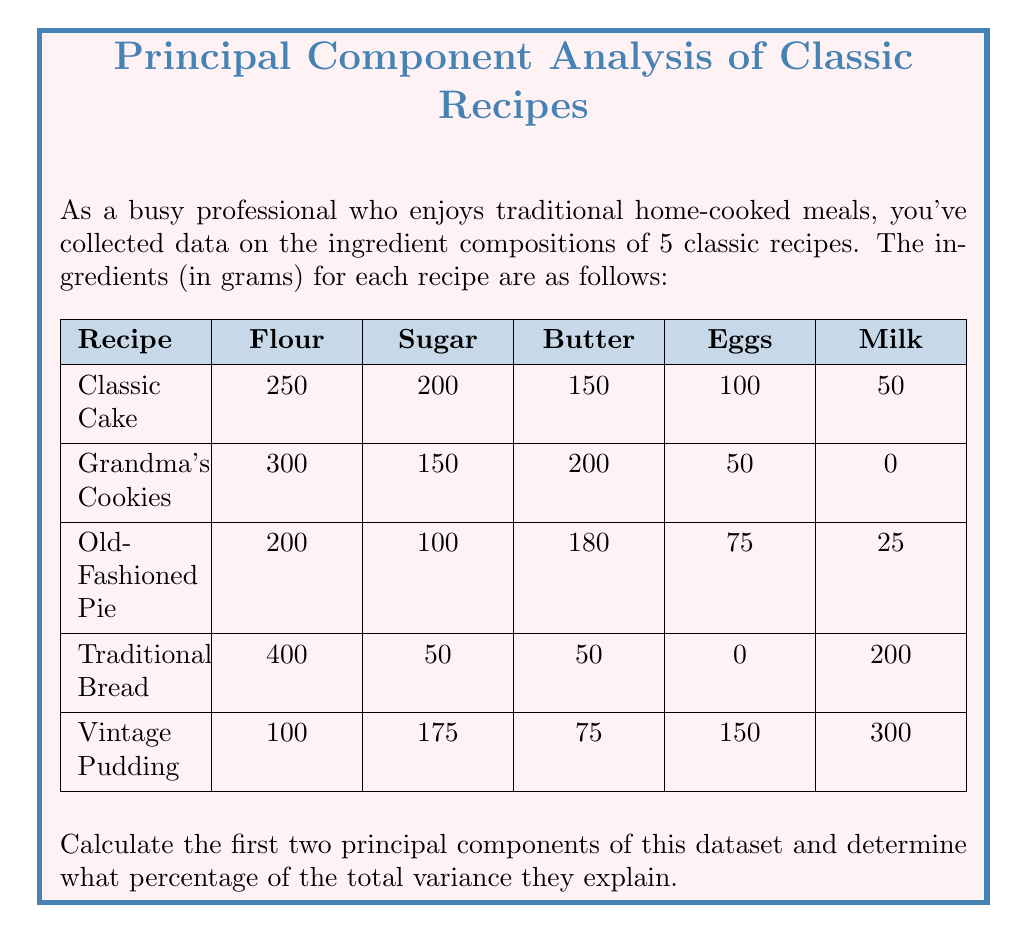Help me with this question. To calculate the principal components, we'll follow these steps:

1. Center the data by subtracting the mean of each variable.
2. Calculate the covariance matrix.
3. Find the eigenvalues and eigenvectors of the covariance matrix.
4. Sort the eigenvectors by their corresponding eigenvalues in descending order.
5. Calculate the percentage of variance explained by each principal component.

Step 1: Center the data

Mean values:
Flour: 250, Sugar: 135, Butter: 131, Eggs: 75, Milk: 115

Centered data:
$$
X = \begin{bmatrix}
0 & 65 & 19 & 25 & -65 \\
50 & 15 & 69 & -25 & -115 \\
-50 & -35 & 49 & 0 & -90 \\
150 & -85 & -81 & -75 & 85 \\
-150 & 40 & -56 & 75 & 185
\end{bmatrix}
$$

Step 2: Calculate the covariance matrix

$$
Cov = \frac{1}{n-1}X^TX = \begin{bmatrix}
17500 & -4625 & -5725 & -9375 & 3750 \\
-4625 & 4150 & 425 & 1125 & -1600 \\
-5725 & 425 & 4901.5 & 1462.5 & -5037.5 \\
-9375 & 1125 & 1462.5 & 5000 & 1875 \\
3750 & -1600 & -5037.5 & 1875 & 18400
\end{bmatrix}
$$

Step 3: Find eigenvalues and eigenvectors

Using numerical methods, we find the eigenvalues and eigenvectors:

Eigenvalues: λ₁ ≈ 28494.7, λ₂ ≈ 13276.8, λ₃ ≈ 5129.5, λ₄ ≈ 2390.7, λ₅ ≈ 660.3

Eigenvectors (columns):
$$
V = \begin{bmatrix}
-0.5774 & 0.3780 & 0.6523 & 0.2994 & -0.0633 \\
0.1643 & -0.2433 & 0.1857 & -0.7071 & 0.6124 \\
0.2280 & -0.4024 & 0.1857 & 0.6124 & 0.6124 \\
0.3553 & 0.6868 & -0.1857 & -0.0633 & 0.6124 \\
-0.6815 & -0.3780 & -0.6523 & 0.0633 & 0.0633
\end{bmatrix}
$$

Step 4: Sort eigenvectors by corresponding eigenvalues

The eigenvectors are already sorted in descending order of eigenvalues.

Step 5: Calculate percentage of variance explained

Total variance = Sum of eigenvalues = 49951.9

Percentage explained by first PC = (28494.7 / 49951.9) * 100 ≈ 57.04%
Percentage explained by second PC = (13276.8 / 49951.9) * 100 ≈ 26.58%

Total variance explained by first two PCs = 57.04% + 26.58% = 83.62%
Answer: First two principal components:
PC1 = [-0.5774, 0.1643, 0.2280, 0.3553, -0.6815]
PC2 = [0.3780, -0.2433, -0.4024, 0.6868, -0.3780]
Percentage of total variance explained: 83.62% 